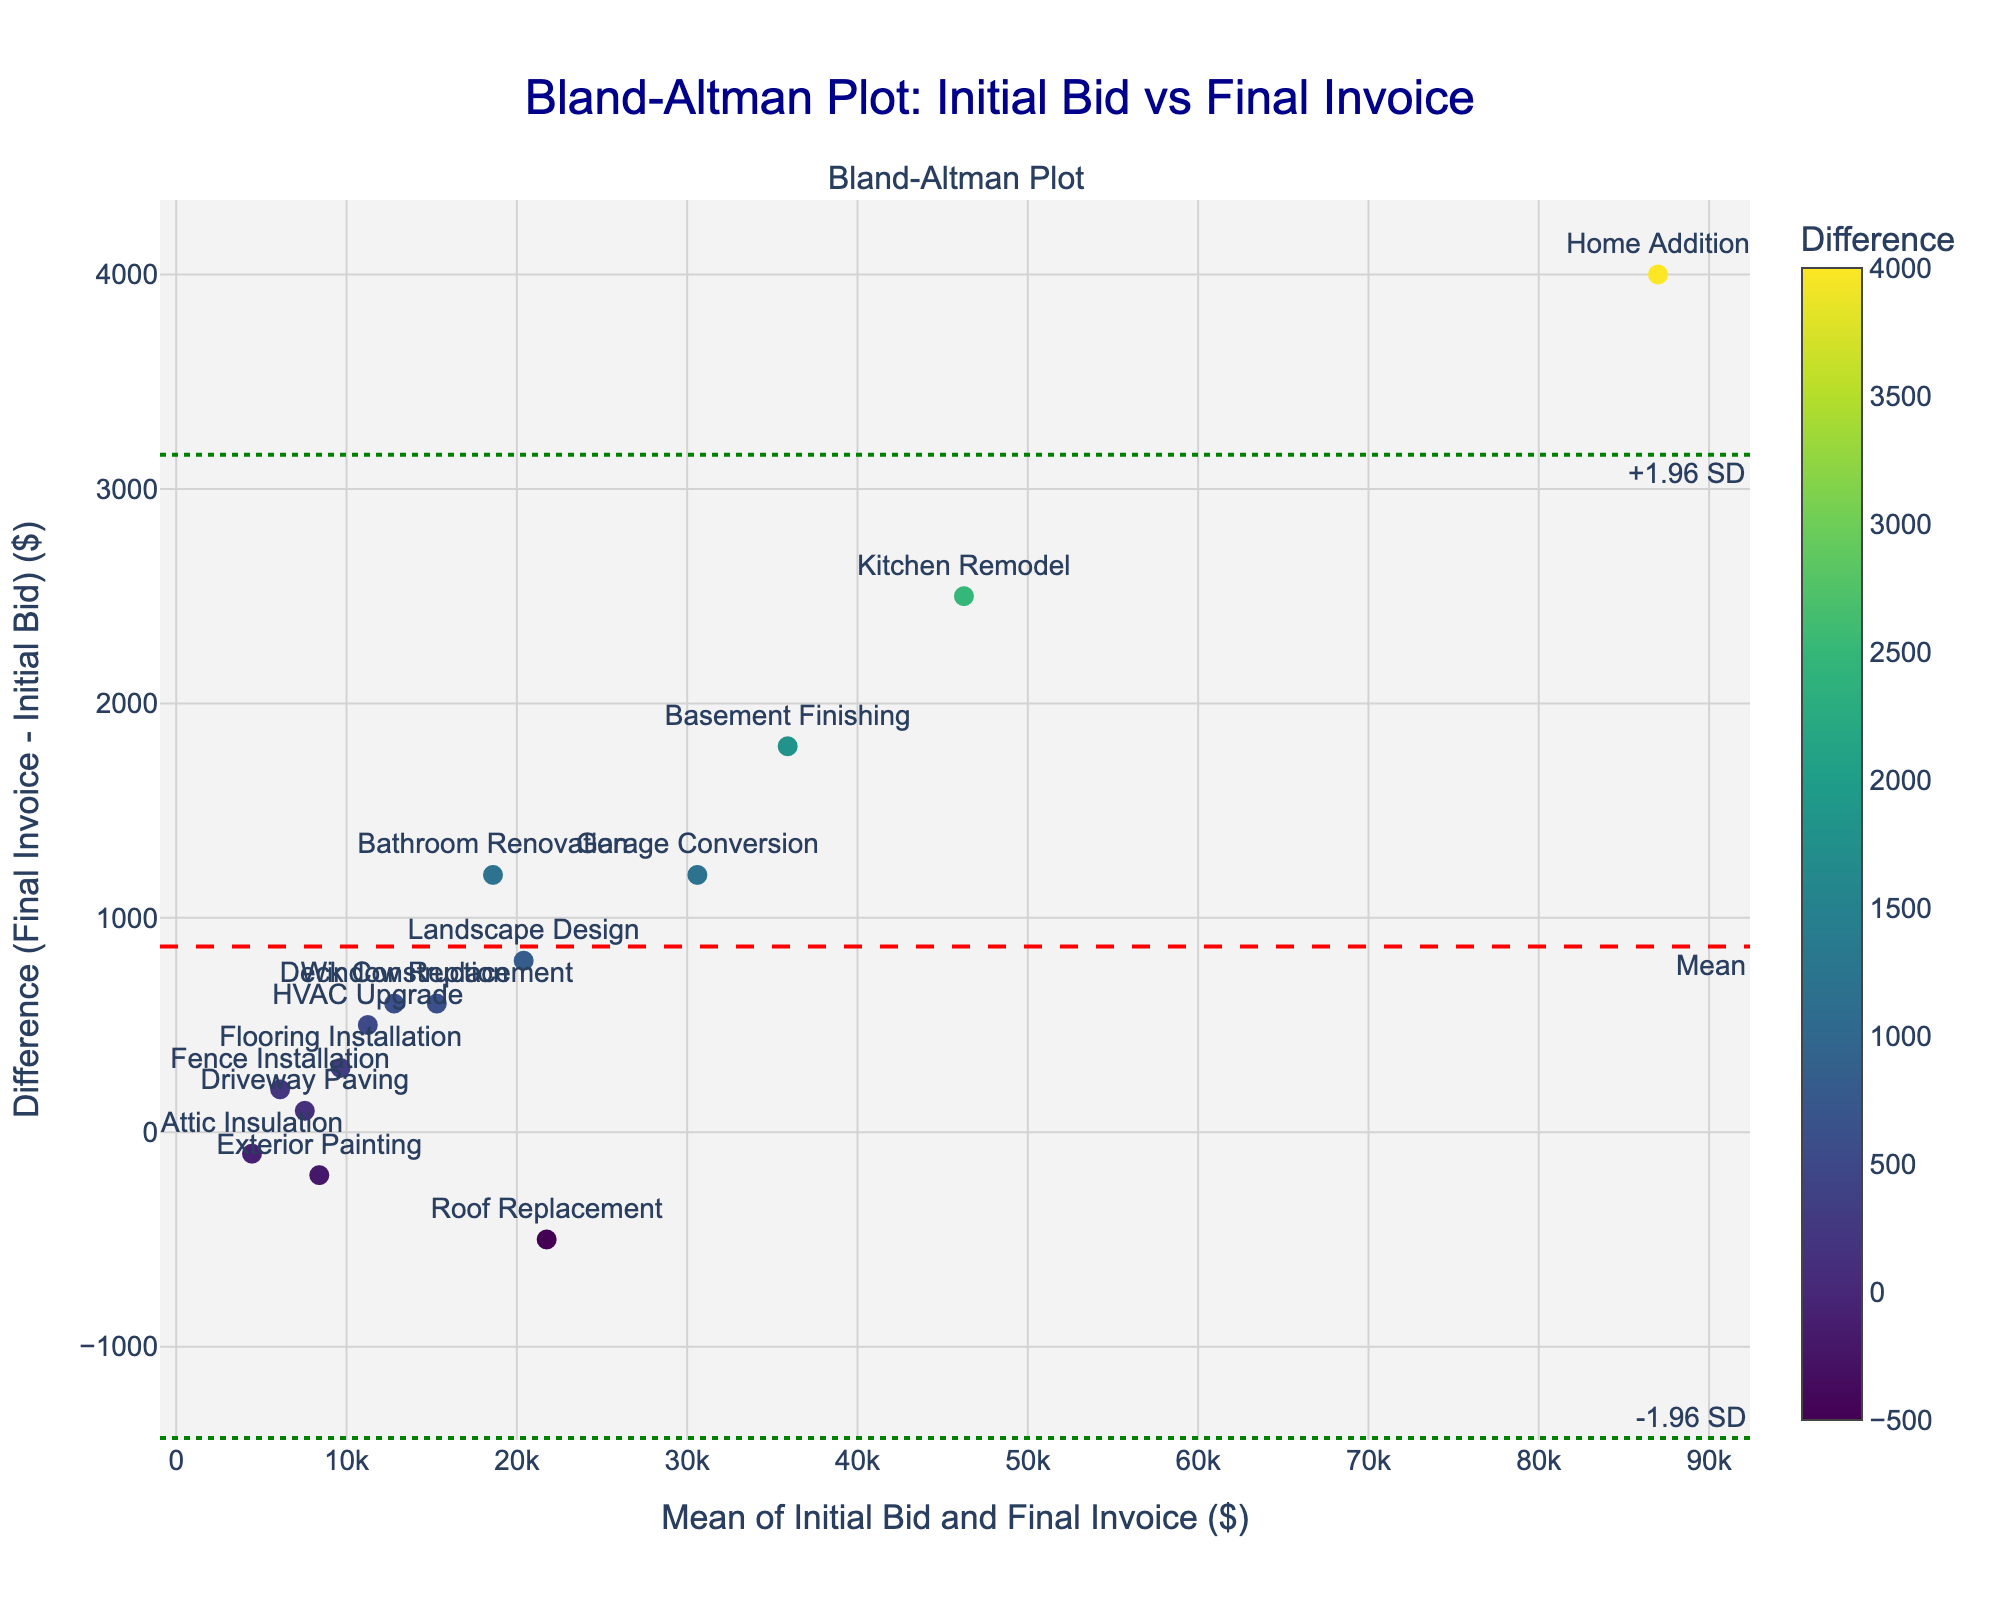what is the title of the plot? The title is usually positioned at the top of the plot and describes what the plot represents. In this case, the title reads "Bland-Altman Plot: Initial Bid vs Final Invoice".
Answer: Bland-Altman Plot: Initial Bid vs Final Invoice What does the x-axis represent? The x-axis typically has a label indicating its meaning. Here, it is labeled "Mean of Initial Bid and Final Invoice ($)".
Answer: Mean of Initial Bid and Final Invoice ($) Which project has the highest difference between the final invoice and the initial bid? The difference values are indicated by the y-position of the data points on the plot. By identifying the highest point on the y-axis, we see that "Home Addition" has the largest difference.
Answer: Home Addition What is the mean difference between the final invoice and the initial bid? The mean difference is represented by a dashed red line in the plot and is specifically annotated as "Mean". The value of this line is the mean difference.
Answer: Mean What color scale is used for the data points, and what does the color represent? The colors of the data points are indicated by the colorbar alongside the plot, and they represent different values of the "Difference" between final invoices and initial bids. The specific color scale being used is 'Viridis'.
Answer: Viridis Which projects fall outside the limits of agreement (+1.96 SD and -1.96 SD)? Projects outside the limits of agreement are those whose data points fall beyond the dotted green lines representing +1.96 SD and -1.96 SD. The projects exceeding these bounds need to be identified from those points.
Answer: None What does the y-axis represent? The y-axis has a label that defines its meaning. In this plot, it represents the "Difference (Final Invoice - Initial Bid) ($)".
Answer: Difference (Final Invoice - Initial Bid) ($) Which project had the smallest mean of the initial bid and final invoice? The means are represented by the x-position of the data points on the plot. The "Attic Insulation" project is the furthest to the left on the x-axis indicating the smallest mean.
Answer: Attic Insulation How many projects have a final invoice higher than the initial bid? The points above the zero line on the y-axis indicate projects where the final invoice is higher than the initial bid. Counting the number of points above this line gives the number of projects.
Answer: 12 